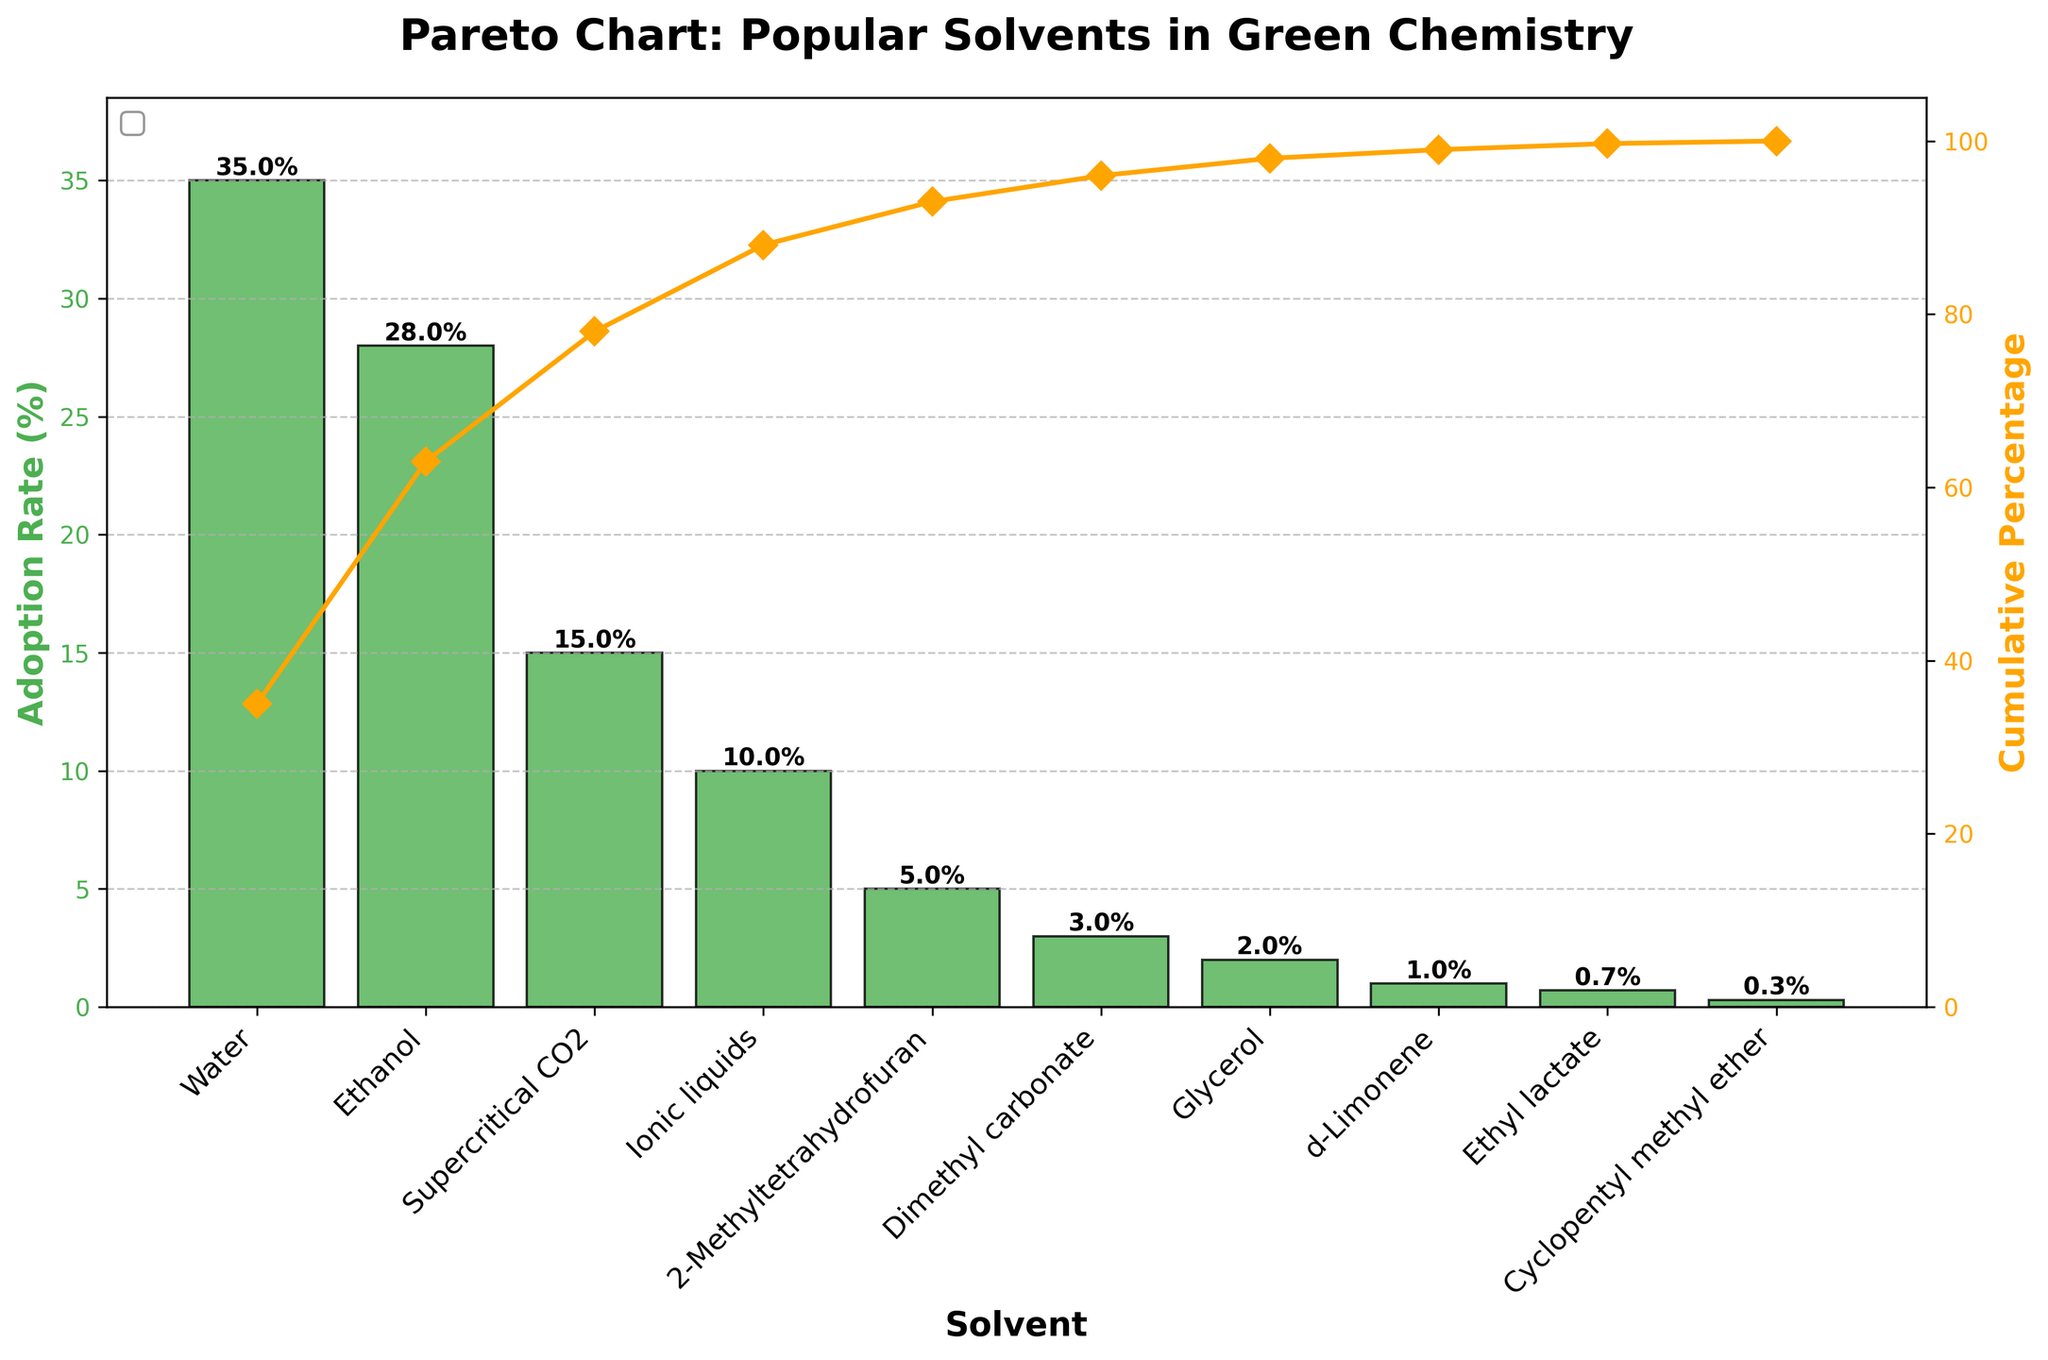What is the title of the chart? The title is displayed at the top of the chart. It reads "Pareto Chart: Popular Solvents in Green Chemistry".
Answer: Pareto Chart: Popular Solvents in Green Chemistry Which solvent has the highest adoption rate? By looking at the heights of the bars in the chart, the tallest bar represents the solvent with the highest adoption rate, which is water.
Answer: Water What is the cumulative percentage for the top three solvents? Referring to the cumulative percentage line in the chart, it shows the cumulative percentage for the solvents with the highest adoption rates. Summing the rates for Water (35%), Ethanol (28%), and Supercritical CO2 (15%), the cumulative percentage equals 78%.
Answer: 78% Which solvent has a use rate of 5%? By looking at the values at the top of each bar in the chart, the solvent with a use rate of 5% is identified, which is 2-Methyltetrahydrofuran.
Answer: 2-Methyltetrahydrofuran What is the adoption rate of Ethyl lactate? The bar chart displays the adoption rate values at the top of each bar, showing that Ethyl lactate has an adoption rate of 0.7%.
Answer: 0.7% Which two solvents have the lowest adoption rates? The bars representing the solvents' adoption rates show the shortest bars, which correspond to the lowest adoption rates. The two solvents with the lowest adoption rates are Cyclopentyl methyl ether and Ethyl lactate.
Answer: Cyclopentyl methyl ether and Ethyl lactate What is the cumulative percentage after 2-Methyltetrahydrofuran? Referring to the cumulative percentage line, the cumulative percentage after 2-Methyltetrahydrofuran (the fifth solvent) is 93% (sum of rates for Water, Ethanol, Supercritical CO2, Ionic liquids, and 2-Methyltetrahydrofuran).
Answer: 93% How many solvents have an adoption rate of 10% or more? Observing the bar heights and their respective values, the solvents with adoption rates of 10% or more are Water (35%), Ethanol (28%), Supercritical CO2 (15%), and Ionic liquids (10%).
Answer: 4 Which solvent, excluding the top solvent, has the highest cumulative percentage increase? Excluding Water (the top solvent with 35%), the next highest cumulative percentage bar is for Ethanol, increasing the cumulative percentage by 28% from 35% to 63%.
Answer: Ethanol 